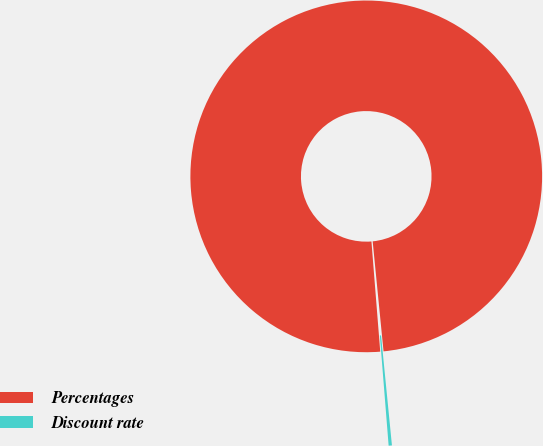Convert chart to OTSL. <chart><loc_0><loc_0><loc_500><loc_500><pie_chart><fcel>Percentages<fcel>Discount rate<nl><fcel>99.7%<fcel>0.3%<nl></chart> 